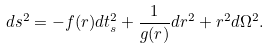Convert formula to latex. <formula><loc_0><loc_0><loc_500><loc_500>d s ^ { 2 } = - f ( r ) d t _ { s } ^ { 2 } + \frac { 1 } { g ( r ) } d r ^ { 2 } + r ^ { 2 } d \Omega ^ { 2 } .</formula> 